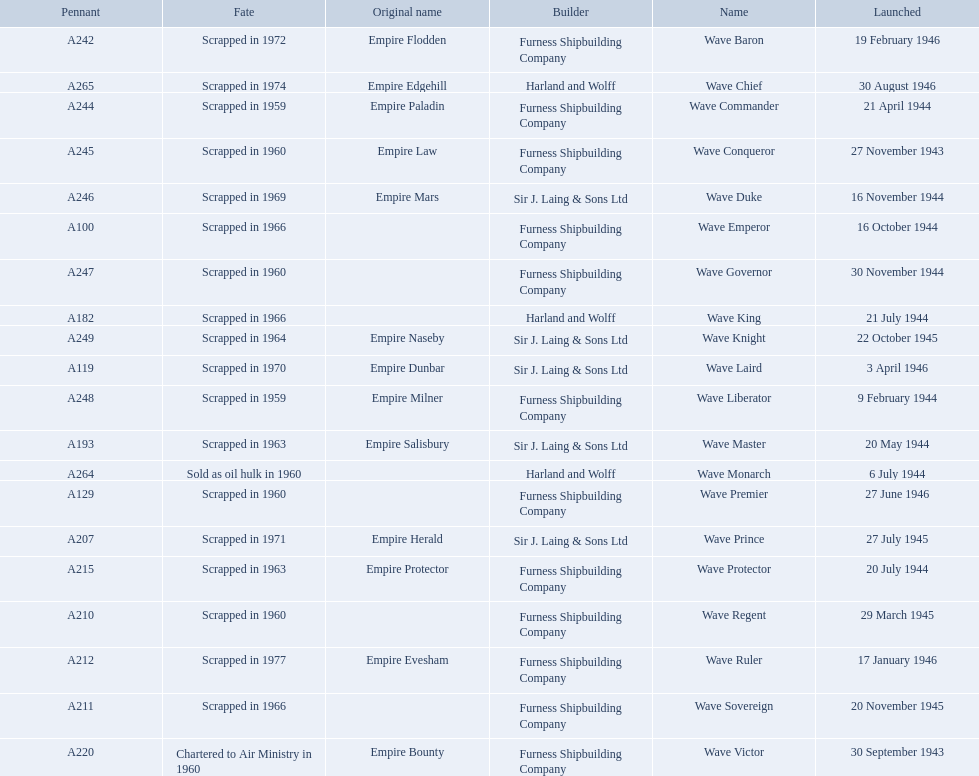What date was the wave victor launched? 30 September 1943. What other oiler was launched that same year? Wave Conqueror. What year was the wave victor launched? 30 September 1943. What other ship was launched in 1943? Wave Conqueror. 